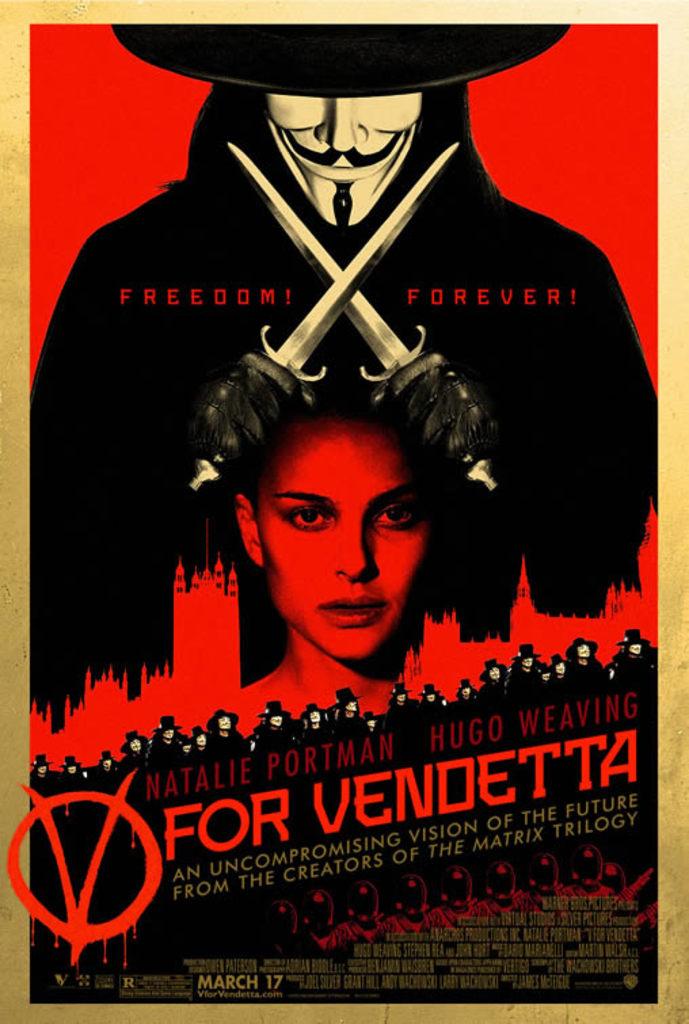When is the release date for the movie?
Make the answer very short. March 17. What is the name of the movie?
Offer a very short reply. V for vendetta. 